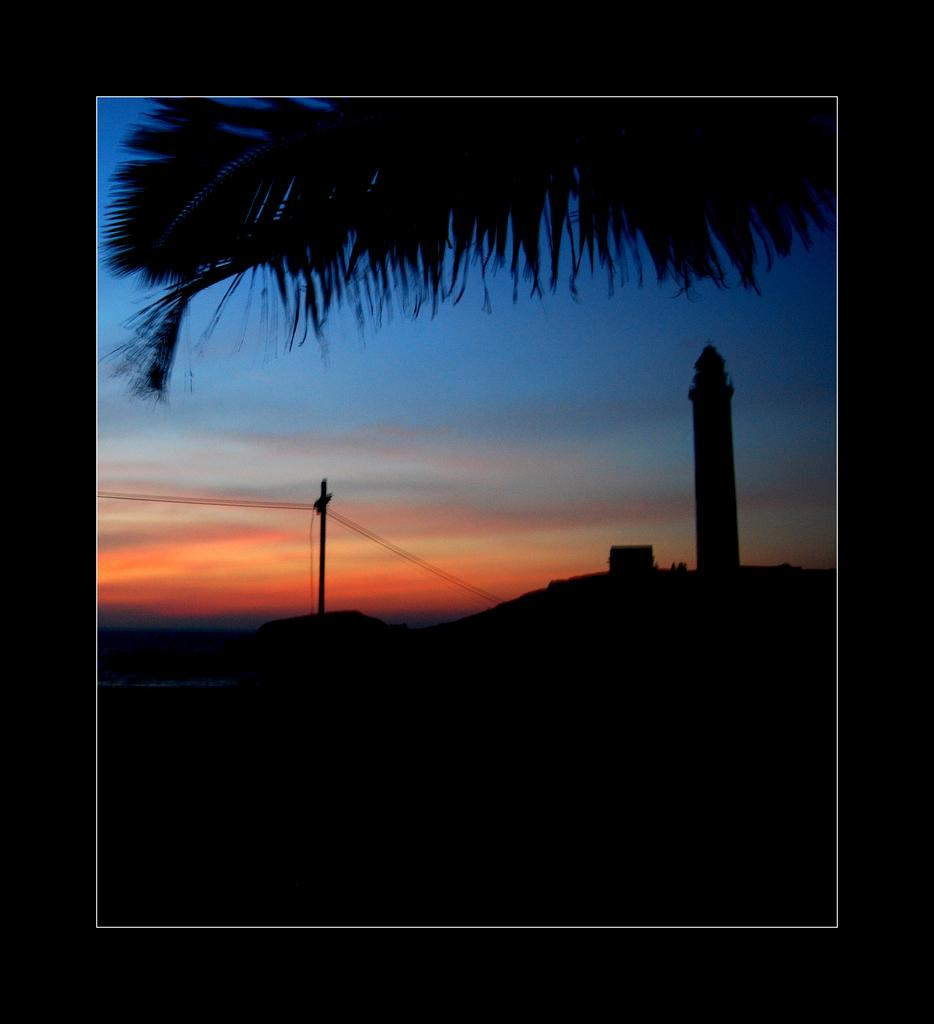What type of photography is depicted in the image? The image is a sunset photography. What is located in the front of the image? There is a tower in the front of the image. How would you describe the color of the sky in the image? The sky is red in color. What type of vegetation can be seen in the image? There are large coconut leaves visible in the image. What type of reaction can be seen on the canvas in the image? There is no canvas present in the image, and therefore no reaction can be observed. 